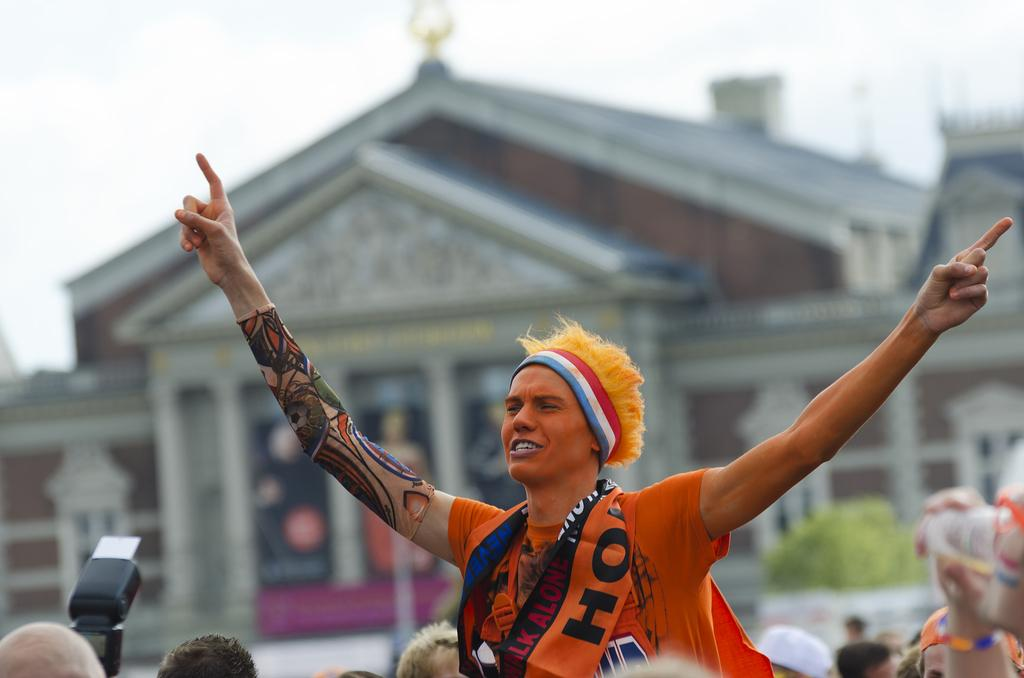Who or what is present in the image? There are people in the image. What object can be seen in the hands of the people or nearby? There is a camera visible in the image. Can you describe the background of the image? The background of the image is blurry, but there is a building, plants, and the sky visible. How many screws are visible on the camera in the image? There is no mention of screws on the camera in the image, so we cannot determine the number of screws. 